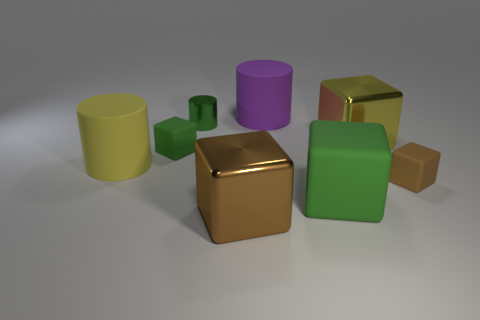What time of day does the lighting in this image resemble? The soft and diffused lighting in this image suggests an indoor environment; therefore, it doesn't directly correspond to a specific time of day. It resembles the type of ambient light you might find on an overcast day or from indoor artificial lighting. 